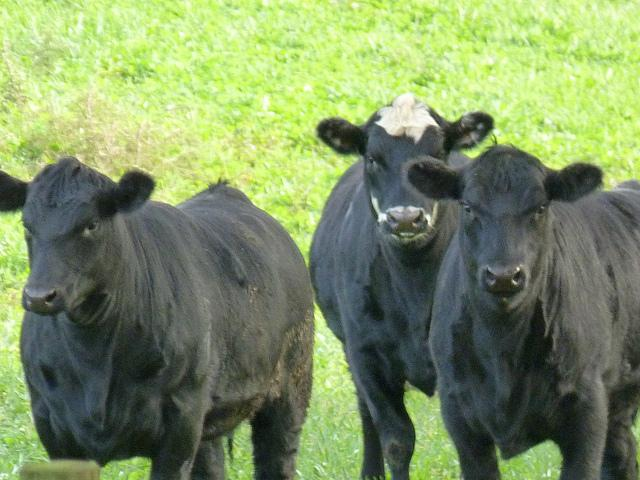How many black cows are standing up in the middle of the pasture? Please explain your reasoning. three. There is a group of three dark cows standing in the grass. 